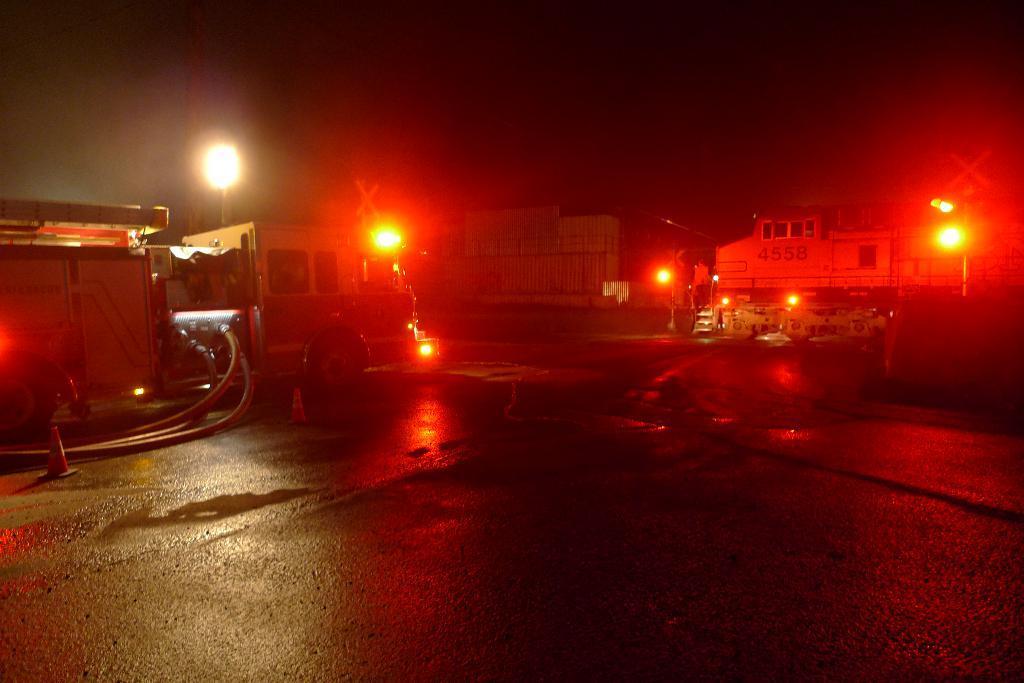In one or two sentences, can you explain what this image depicts? In this image we can see a vehicle on the road. We can also see some pipes and traffic poles on the road. On the backside we can see some lights, poles and the buildings. 